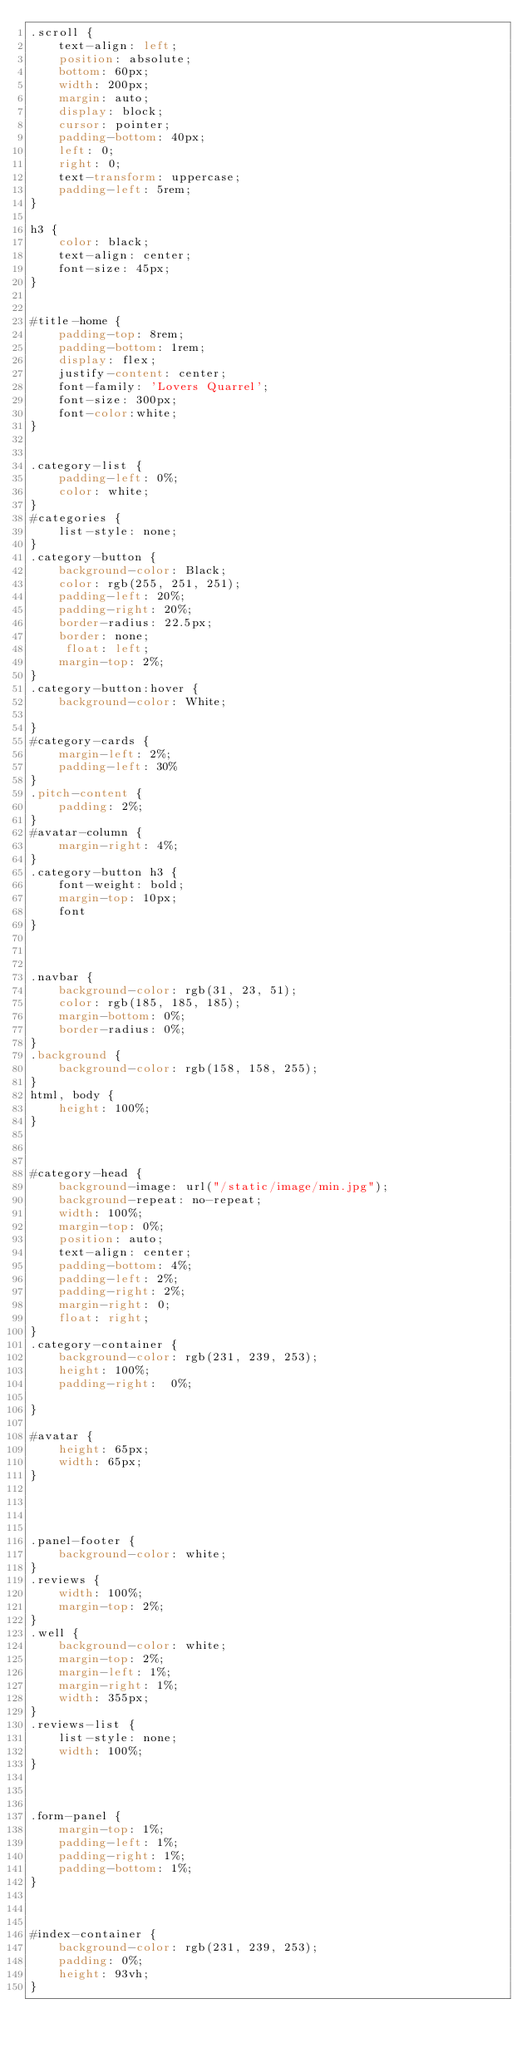Convert code to text. <code><loc_0><loc_0><loc_500><loc_500><_CSS_>.scroll {
    text-align: left;
    position: absolute;
    bottom: 60px;
    width: 200px;
    margin: auto;
    display: block;
    cursor: pointer;
    padding-bottom: 40px;
    left: 0;
    right: 0;
    text-transform: uppercase;
    padding-left: 5rem;
}

h3 {
    color: black;
    text-align: center;
    font-size: 45px;
}


#title-home {
    padding-top: 8rem;
    padding-bottom: 1rem;
    display: flex;
    justify-content: center;
    font-family: 'Lovers Quarrel';
    font-size: 300px;
    font-color:white;
}


.category-list {
    padding-left: 0%;
    color: white;
}
#categories {
    list-style: none;
}
.category-button {
    background-color: Black;
    color: rgb(255, 251, 251);
    padding-left: 20%;
    padding-right: 20%;
    border-radius: 22.5px;
    border: none;
     float: left;
    margin-top: 2%;
}
.category-button:hover {
    background-color: White;
    
}
#category-cards {
    margin-left: 2%;
    padding-left: 30%
}
.pitch-content {
    padding: 2%;
}
#avatar-column {
    margin-right: 4%;
}
.category-button h3 {
    font-weight: bold;
    margin-top: 10px;
    font 
}



.navbar {
    background-color: rgb(31, 23, 51); 
    color: rgb(185, 185, 185);
    margin-bottom: 0%;
    border-radius: 0%;
}
.background {
    background-color: rgb(158, 158, 255);
}
html, body {
    height: 100%;
}
 


#category-head {
    background-image: url("/static/image/min.jpg");
    background-repeat: no-repeat;
    width: 100%;
    margin-top: 0%;
    position: auto;
    text-align: center;
    padding-bottom: 4%;
    padding-left: 2%;
    padding-right: 2%;
    margin-right: 0;
    float: right;
}
.category-container {
    background-color: rgb(231, 239, 253);
    height: 100%;
    padding-right:  0%;

}

#avatar {
    height: 65px;
    width: 65px;
}




.panel-footer {
    background-color: white;
}
.reviews {
    width: 100%;
    margin-top: 2%;
}
.well {
    background-color: white;
    margin-top: 2%;
    margin-left: 1%;
    margin-right: 1%;
    width: 355px;
}
.reviews-list {
    list-style: none;
    width: 100%;
}



.form-panel {
    margin-top: 1%;
    padding-left: 1%;
    padding-right: 1%;
    padding-bottom: 1%;
}



#index-container {
    background-color: rgb(231, 239, 253);
    padding: 0%;
    height: 93vh; 
}
</code> 